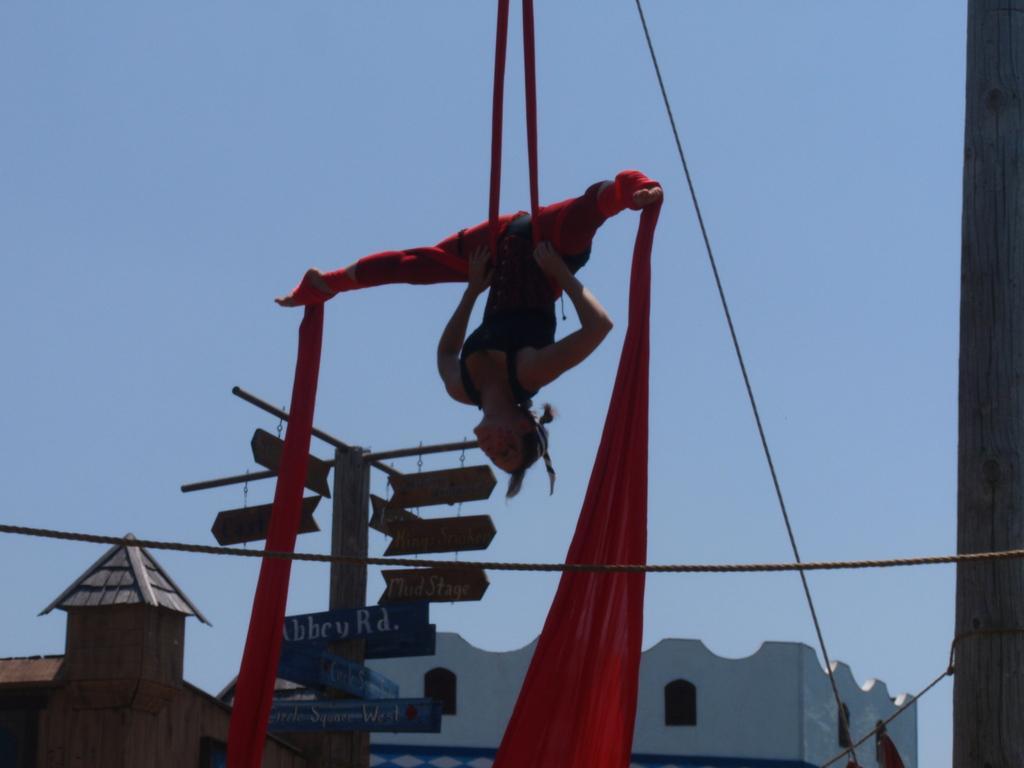Describe this image in one or two sentences. In this image we can see a woman is tied to the clothes in the air. In the background there are buildings, boards on the pole, windows, rope, pole on the right side and sky. 